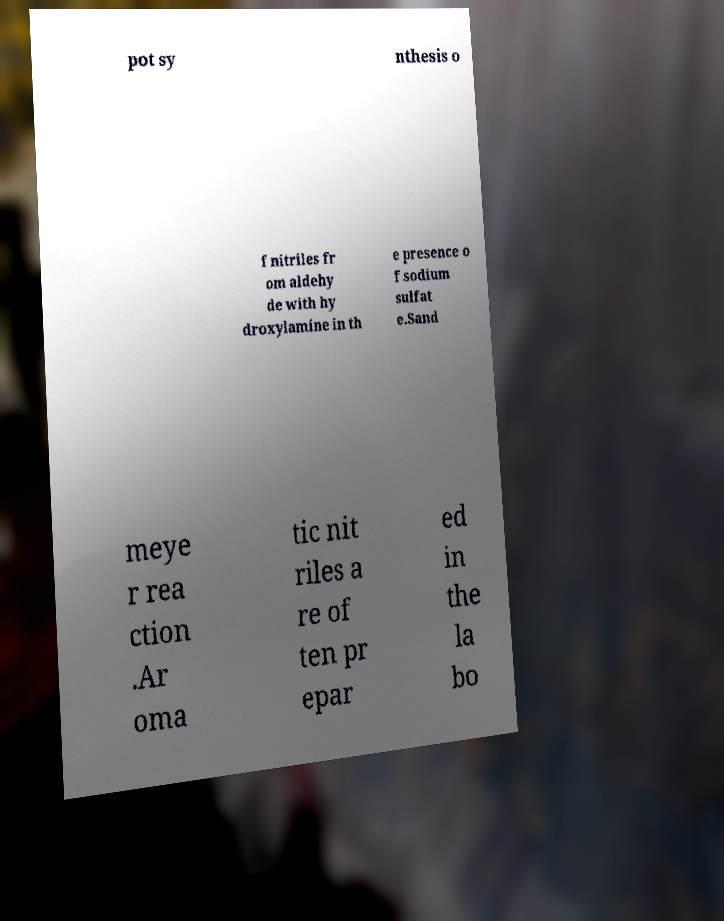Can you accurately transcribe the text from the provided image for me? pot sy nthesis o f nitriles fr om aldehy de with hy droxylamine in th e presence o f sodium sulfat e.Sand meye r rea ction .Ar oma tic nit riles a re of ten pr epar ed in the la bo 